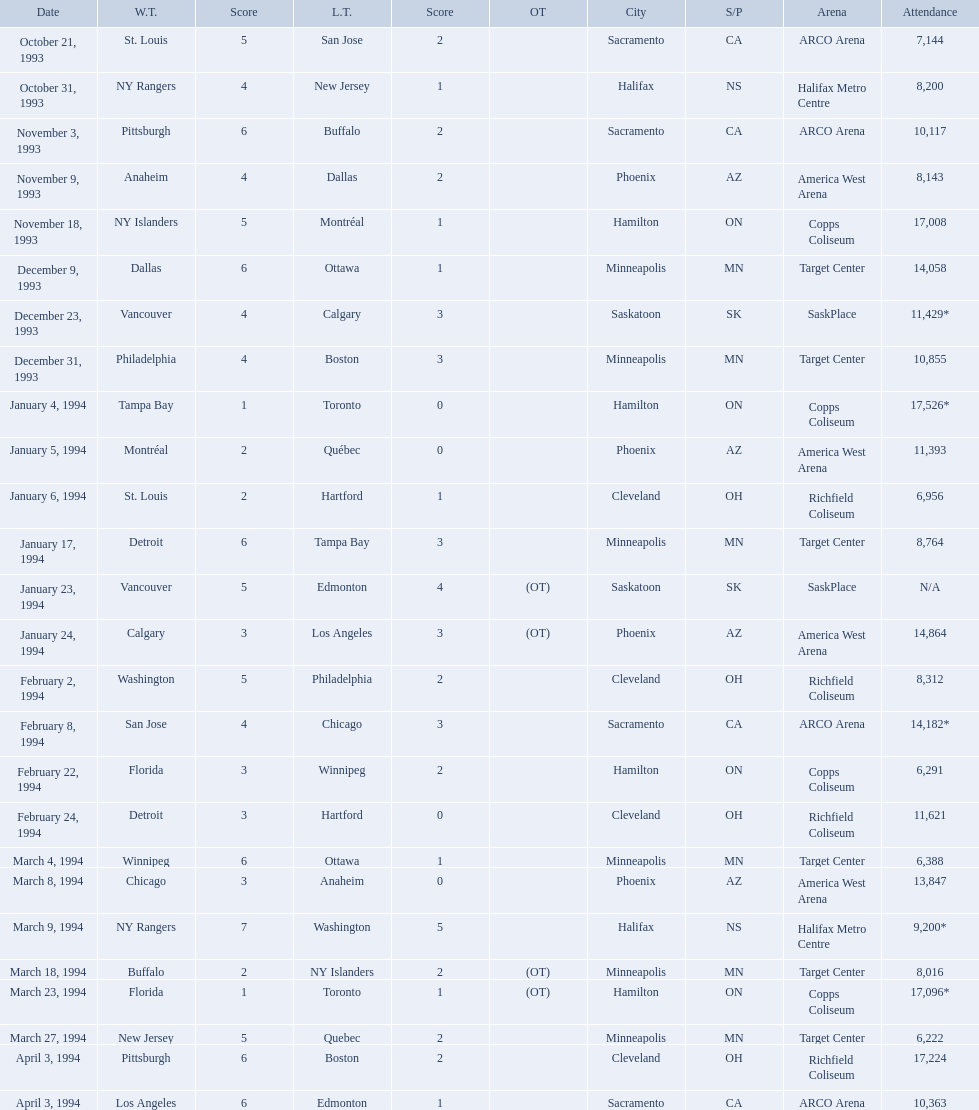On which dates were all the games? October 21, 1993, October 31, 1993, November 3, 1993, November 9, 1993, November 18, 1993, December 9, 1993, December 23, 1993, December 31, 1993, January 4, 1994, January 5, 1994, January 6, 1994, January 17, 1994, January 23, 1994, January 24, 1994, February 2, 1994, February 8, 1994, February 22, 1994, February 24, 1994, March 4, 1994, March 8, 1994, March 9, 1994, March 18, 1994, March 23, 1994, March 27, 1994, April 3, 1994, April 3, 1994. What were the attendances? 7,144, 8,200, 10,117, 8,143, 17,008, 14,058, 11,429*, 10,855, 17,526*, 11,393, 6,956, 8,764, N/A, 14,864, 8,312, 14,182*, 6,291, 11,621, 6,388, 13,847, 9,200*, 8,016, 17,096*, 6,222, 17,224, 10,363. And between december 23, 1993 and january 24, 1994, which game had the highest turnout? January 4, 1994. Which was the highest attendance for a game? 17,526*. What was the date of the game with an attendance of 17,526? January 4, 1994. 